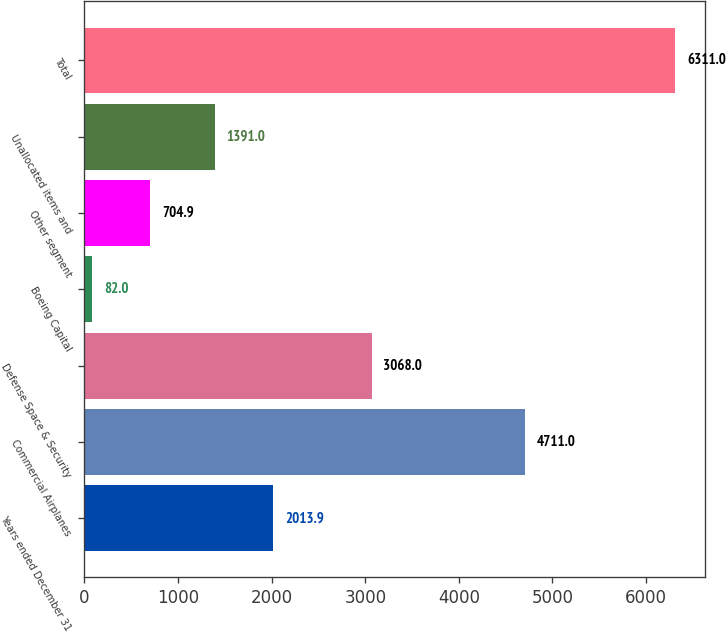Convert chart. <chart><loc_0><loc_0><loc_500><loc_500><bar_chart><fcel>Years ended December 31<fcel>Commercial Airplanes<fcel>Defense Space & Security<fcel>Boeing Capital<fcel>Other segment<fcel>Unallocated items and<fcel>Total<nl><fcel>2013.9<fcel>4711<fcel>3068<fcel>82<fcel>704.9<fcel>1391<fcel>6311<nl></chart> 